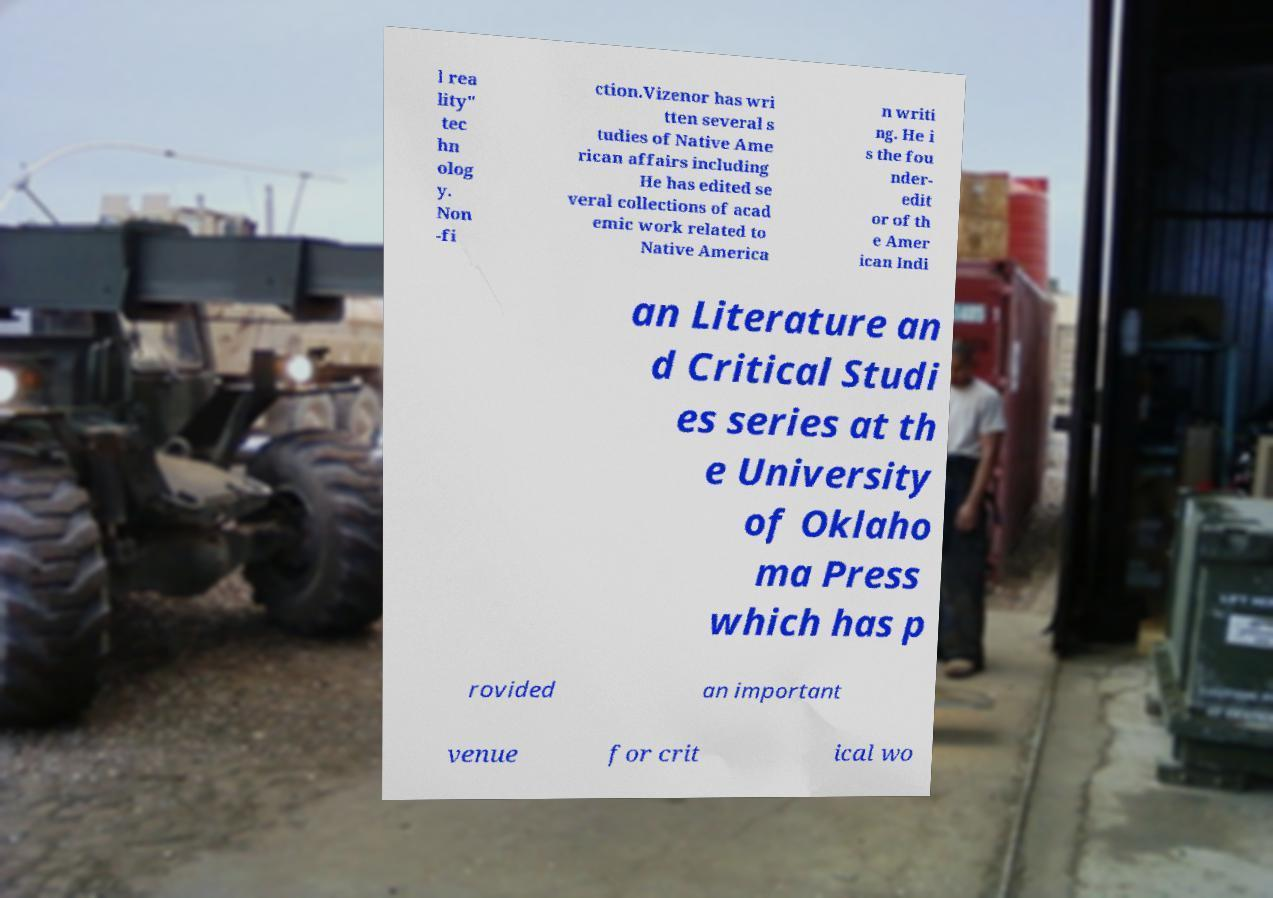What messages or text are displayed in this image? I need them in a readable, typed format. l rea lity" tec hn olog y. Non -fi ction.Vizenor has wri tten several s tudies of Native Ame rican affairs including He has edited se veral collections of acad emic work related to Native America n writi ng. He i s the fou nder- edit or of th e Amer ican Indi an Literature an d Critical Studi es series at th e University of Oklaho ma Press which has p rovided an important venue for crit ical wo 